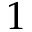<formula> <loc_0><loc_0><loc_500><loc_500>1</formula> 